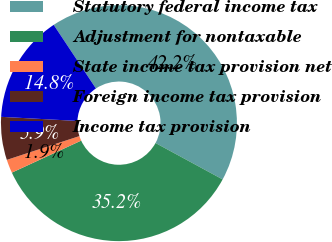Convert chart to OTSL. <chart><loc_0><loc_0><loc_500><loc_500><pie_chart><fcel>Statutory federal income tax<fcel>Adjustment for nontaxable<fcel>State income tax provision net<fcel>Foreign income tax provision<fcel>Income tax provision<nl><fcel>42.24%<fcel>35.2%<fcel>1.85%<fcel>5.89%<fcel>14.82%<nl></chart> 